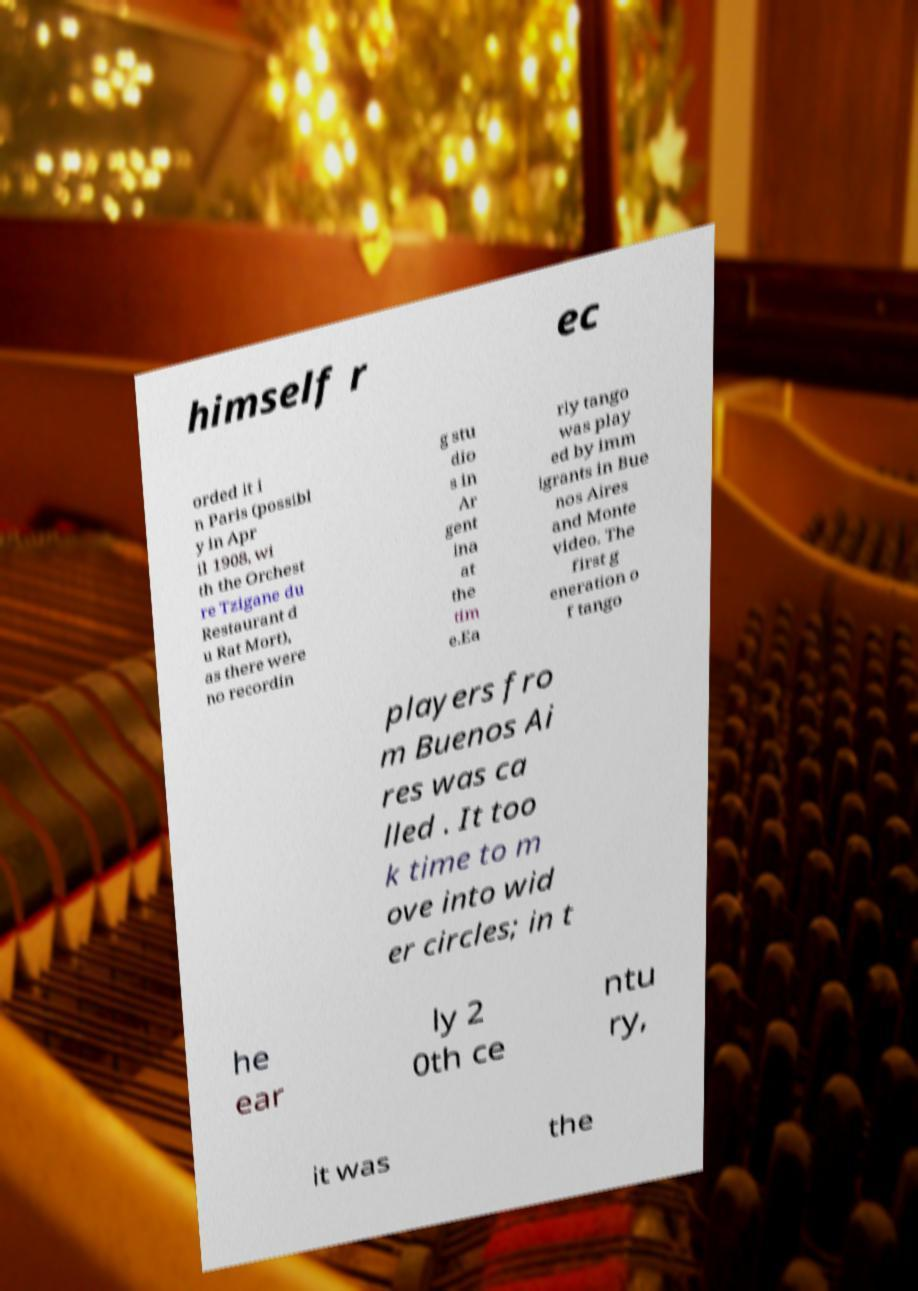Can you read and provide the text displayed in the image?This photo seems to have some interesting text. Can you extract and type it out for me? himself r ec orded it i n Paris (possibl y in Apr il 1908, wi th the Orchest re Tzigane du Restaurant d u Rat Mort), as there were no recordin g stu dio s in Ar gent ina at the tim e.Ea rly tango was play ed by imm igrants in Bue nos Aires and Monte video. The first g eneration o f tango players fro m Buenos Ai res was ca lled . It too k time to m ove into wid er circles; in t he ear ly 2 0th ce ntu ry, it was the 